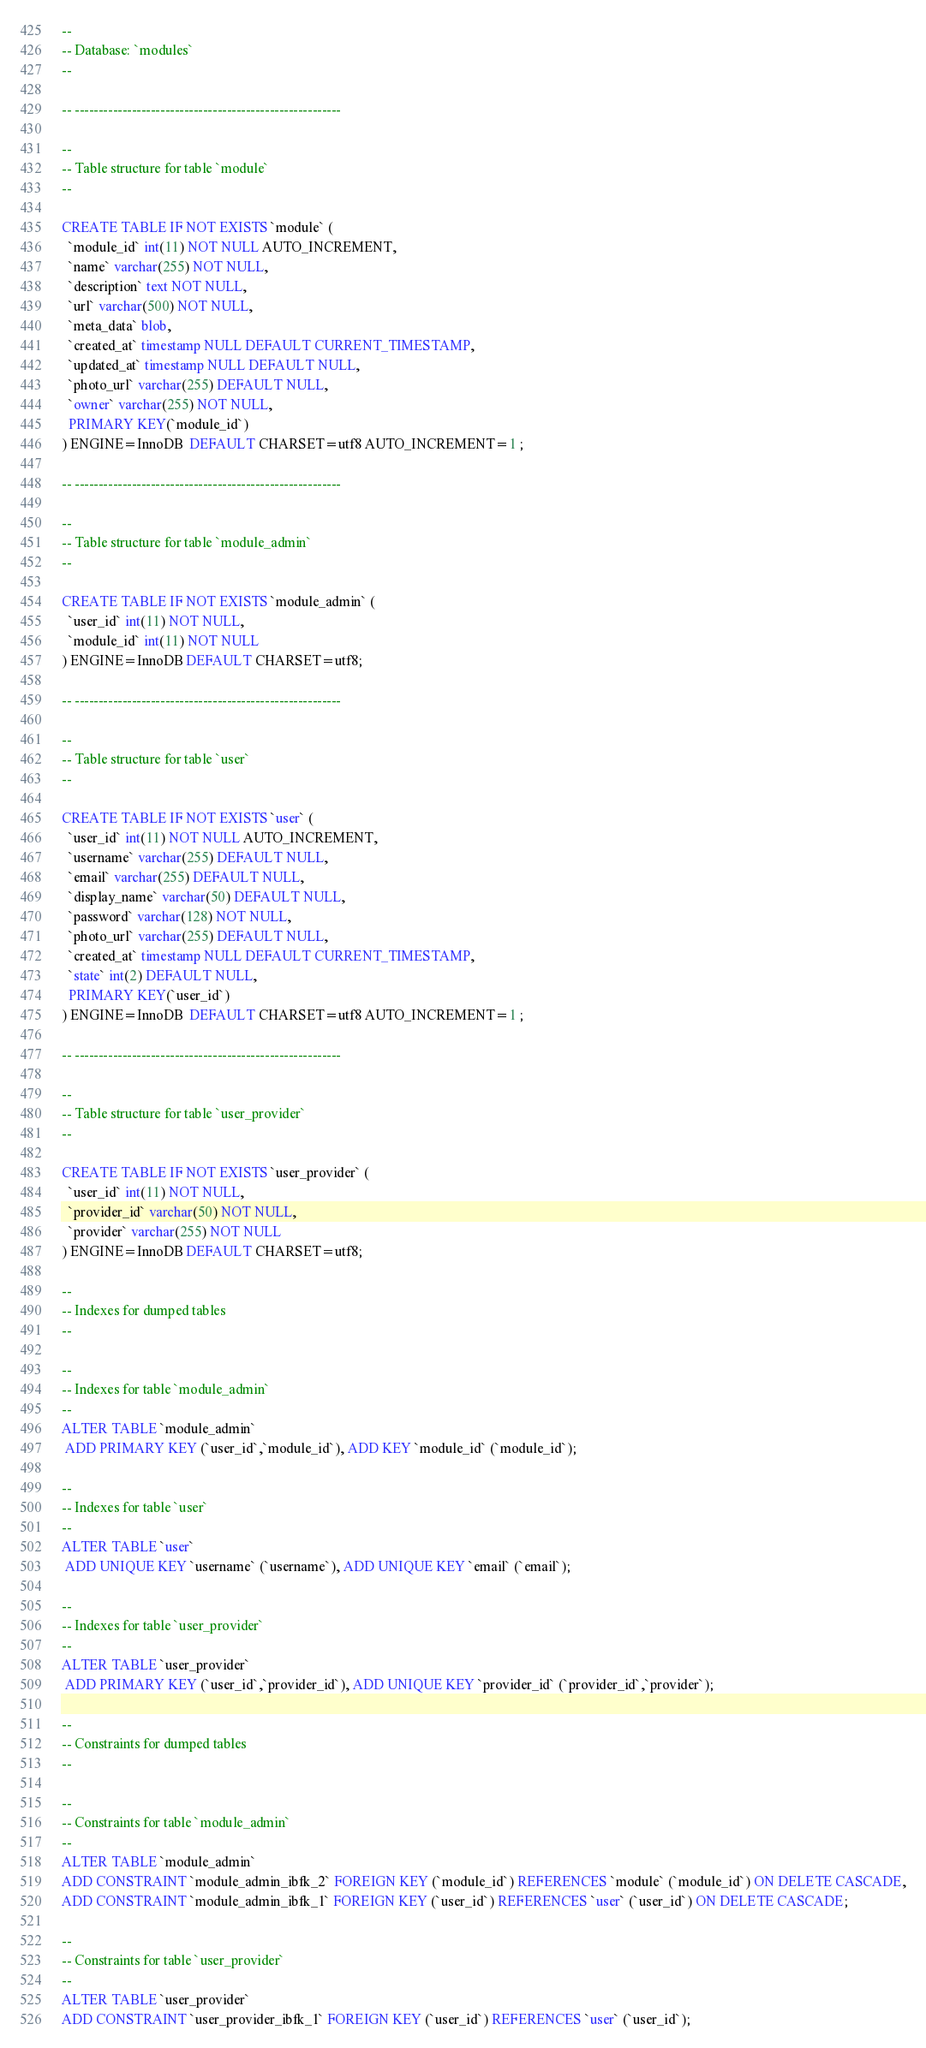<code> <loc_0><loc_0><loc_500><loc_500><_SQL_>--
-- Database: `modules`
--

-- --------------------------------------------------------

--
-- Table structure for table `module`
--

CREATE TABLE IF NOT EXISTS `module` (
  `module_id` int(11) NOT NULL AUTO_INCREMENT,
  `name` varchar(255) NOT NULL,
  `description` text NOT NULL,
  `url` varchar(500) NOT NULL,
  `meta_data` blob,
  `created_at` timestamp NULL DEFAULT CURRENT_TIMESTAMP,
  `updated_at` timestamp NULL DEFAULT NULL,
  `photo_url` varchar(255) DEFAULT NULL,
  `owner` varchar(255) NOT NULL,
  PRIMARY KEY(`module_id`)
) ENGINE=InnoDB  DEFAULT CHARSET=utf8 AUTO_INCREMENT=1 ;

-- --------------------------------------------------------

--
-- Table structure for table `module_admin`
--

CREATE TABLE IF NOT EXISTS `module_admin` (
  `user_id` int(11) NOT NULL,
  `module_id` int(11) NOT NULL
) ENGINE=InnoDB DEFAULT CHARSET=utf8;

-- --------------------------------------------------------

--
-- Table structure for table `user`
--

CREATE TABLE IF NOT EXISTS `user` (
  `user_id` int(11) NOT NULL AUTO_INCREMENT,
  `username` varchar(255) DEFAULT NULL,
  `email` varchar(255) DEFAULT NULL,
  `display_name` varchar(50) DEFAULT NULL,
  `password` varchar(128) NOT NULL,
  `photo_url` varchar(255) DEFAULT NULL,
  `created_at` timestamp NULL DEFAULT CURRENT_TIMESTAMP,
  `state` int(2) DEFAULT NULL,
  PRIMARY KEY(`user_id`)
) ENGINE=InnoDB  DEFAULT CHARSET=utf8 AUTO_INCREMENT=1 ;

-- --------------------------------------------------------

--
-- Table structure for table `user_provider`
--

CREATE TABLE IF NOT EXISTS `user_provider` (
  `user_id` int(11) NOT NULL,
  `provider_id` varchar(50) NOT NULL,
  `provider` varchar(255) NOT NULL
) ENGINE=InnoDB DEFAULT CHARSET=utf8;

--
-- Indexes for dumped tables
--

--
-- Indexes for table `module_admin`
--
ALTER TABLE `module_admin`
 ADD PRIMARY KEY (`user_id`,`module_id`), ADD KEY `module_id` (`module_id`);

--
-- Indexes for table `user`
--
ALTER TABLE `user`
 ADD UNIQUE KEY `username` (`username`), ADD UNIQUE KEY `email` (`email`);

--
-- Indexes for table `user_provider`
--
ALTER TABLE `user_provider`
 ADD PRIMARY KEY (`user_id`,`provider_id`), ADD UNIQUE KEY `provider_id` (`provider_id`,`provider`);

--
-- Constraints for dumped tables
--

--
-- Constraints for table `module_admin`
--
ALTER TABLE `module_admin`
ADD CONSTRAINT `module_admin_ibfk_2` FOREIGN KEY (`module_id`) REFERENCES `module` (`module_id`) ON DELETE CASCADE,
ADD CONSTRAINT `module_admin_ibfk_1` FOREIGN KEY (`user_id`) REFERENCES `user` (`user_id`) ON DELETE CASCADE;

--
-- Constraints for table `user_provider`
--
ALTER TABLE `user_provider`
ADD CONSTRAINT `user_provider_ibfk_1` FOREIGN KEY (`user_id`) REFERENCES `user` (`user_id`);
</code> 